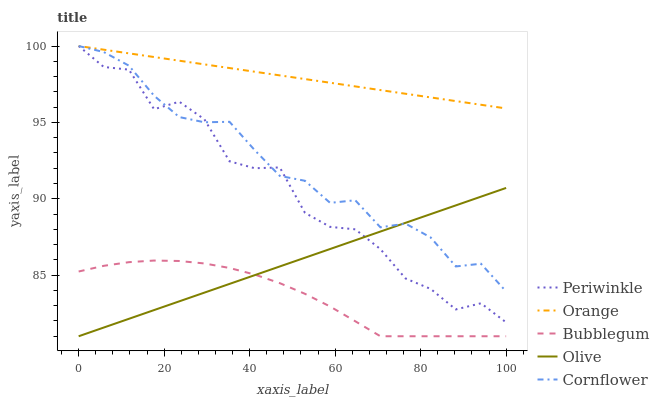Does Bubblegum have the minimum area under the curve?
Answer yes or no. Yes. Does Orange have the maximum area under the curve?
Answer yes or no. Yes. Does Olive have the minimum area under the curve?
Answer yes or no. No. Does Olive have the maximum area under the curve?
Answer yes or no. No. Is Olive the smoothest?
Answer yes or no. Yes. Is Periwinkle the roughest?
Answer yes or no. Yes. Is Periwinkle the smoothest?
Answer yes or no. No. Is Olive the roughest?
Answer yes or no. No. Does Olive have the lowest value?
Answer yes or no. Yes. Does Periwinkle have the lowest value?
Answer yes or no. No. Does Cornflower have the highest value?
Answer yes or no. Yes. Does Olive have the highest value?
Answer yes or no. No. Is Bubblegum less than Orange?
Answer yes or no. Yes. Is Periwinkle greater than Bubblegum?
Answer yes or no. Yes. Does Cornflower intersect Orange?
Answer yes or no. Yes. Is Cornflower less than Orange?
Answer yes or no. No. Is Cornflower greater than Orange?
Answer yes or no. No. Does Bubblegum intersect Orange?
Answer yes or no. No. 